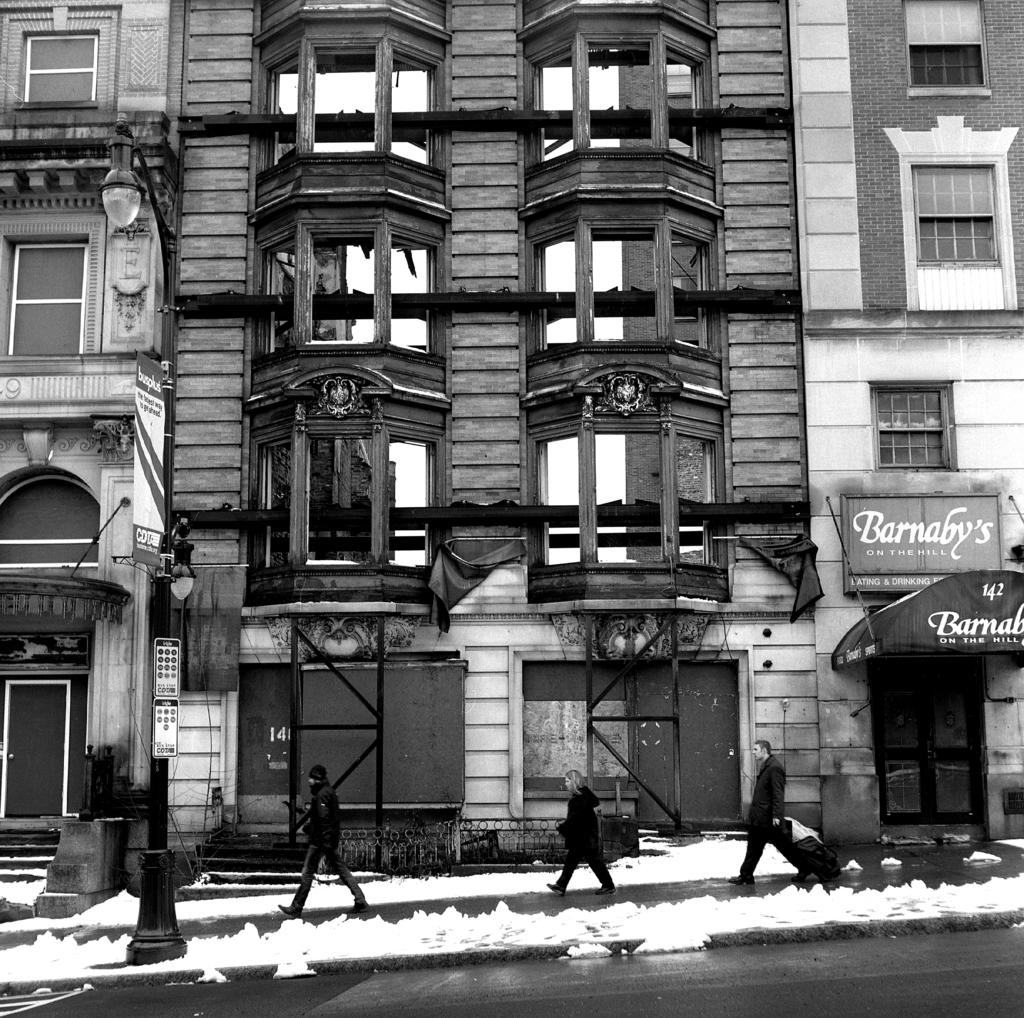What is the color scheme of the image? The image is black and white. What can be seen in terms of people in the image? There is a group of people standing in the image. What is the condition of the road in the image? There is snow on the road in the image. What type of structures are visible in the image? There are buildings visible in the image. What is the source of illumination in the image? There are lights in the image. What are the vertical structures present in the image? There are poles in the image. What are the flat, rectangular objects in the image? There are boards in the image. What is the value of the smashed death in the image? There is no smashed death present in the image; it is a black and white image of a group of people standing in the snow with buildings, lights, poles, and boards visible. 